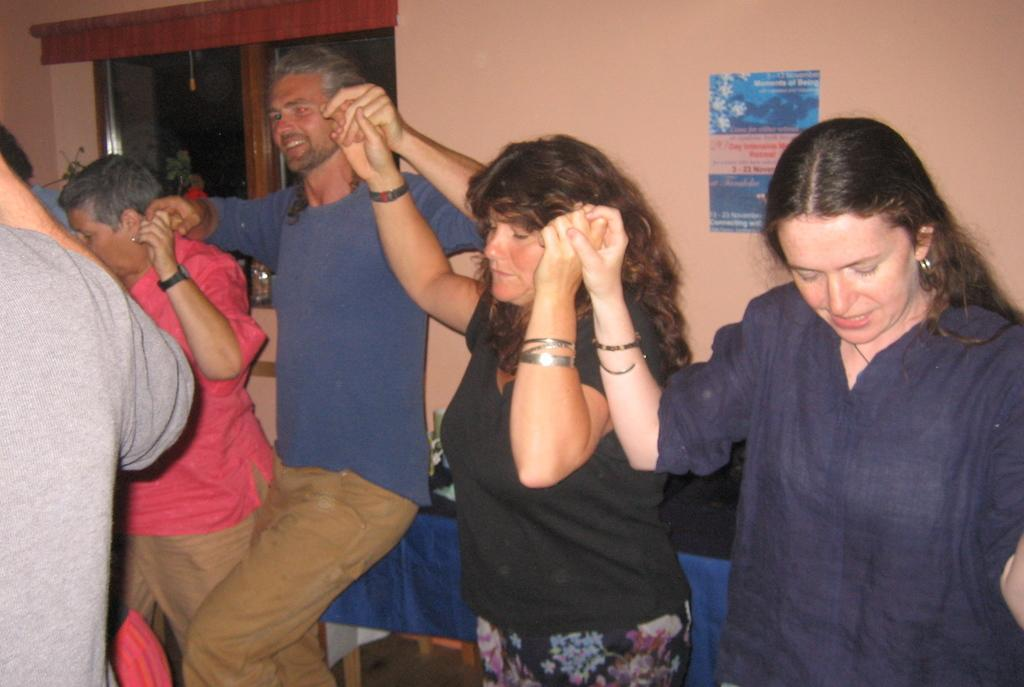How many people are in the image? There are persons in the image, but the exact number is not specified. What can be seen in the background of the image? There is a wall, a window, and a poster in the background of the image. What type of drug can be seen in the poster in the image? There is no drug present in the image, as the facts only mention a poster without specifying its content. 